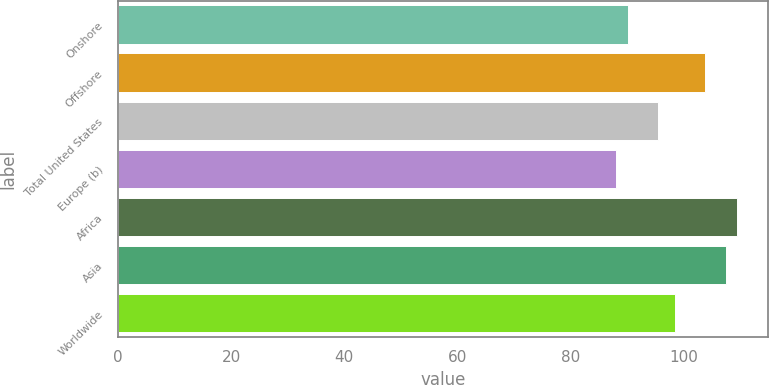Convert chart to OTSL. <chart><loc_0><loc_0><loc_500><loc_500><bar_chart><fcel>Onshore<fcel>Offshore<fcel>Total United States<fcel>Europe (b)<fcel>Africa<fcel>Asia<fcel>Worldwide<nl><fcel>90.1<fcel>103.83<fcel>95.5<fcel>88.03<fcel>109.47<fcel>107.4<fcel>98.48<nl></chart> 